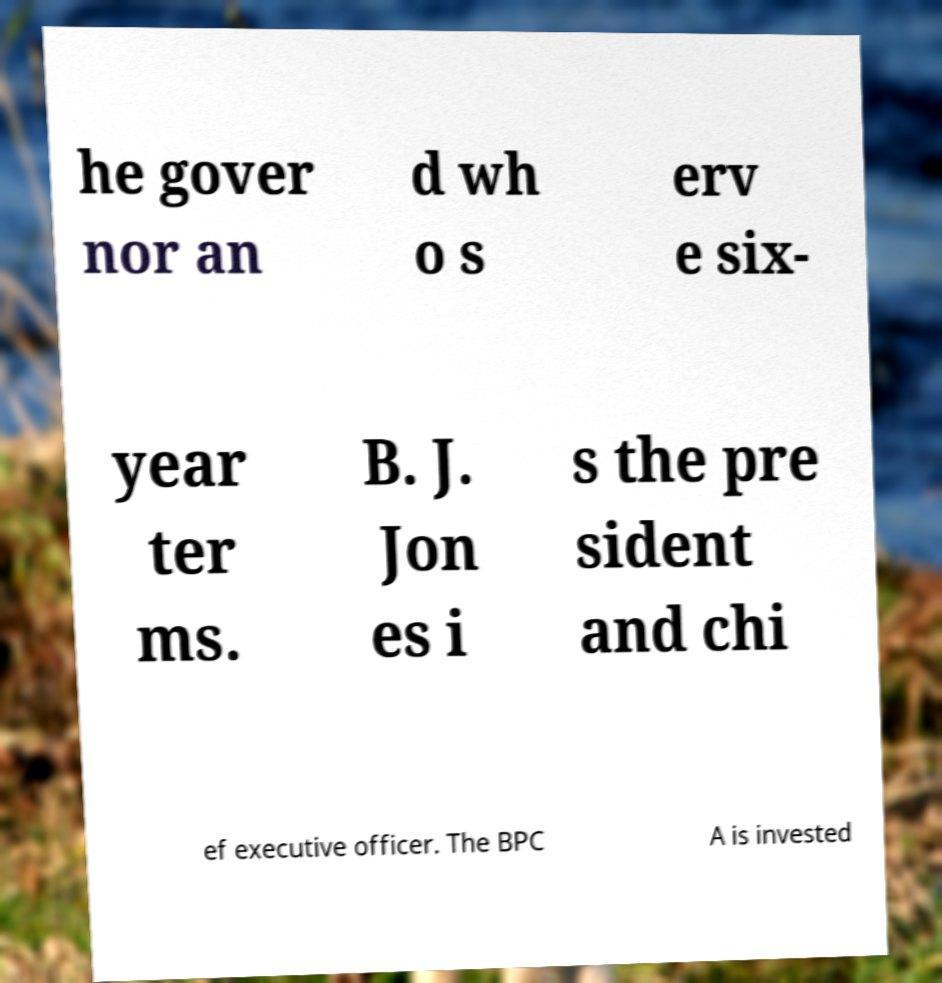I need the written content from this picture converted into text. Can you do that? he gover nor an d wh o s erv e six- year ter ms. B. J. Jon es i s the pre sident and chi ef executive officer. The BPC A is invested 